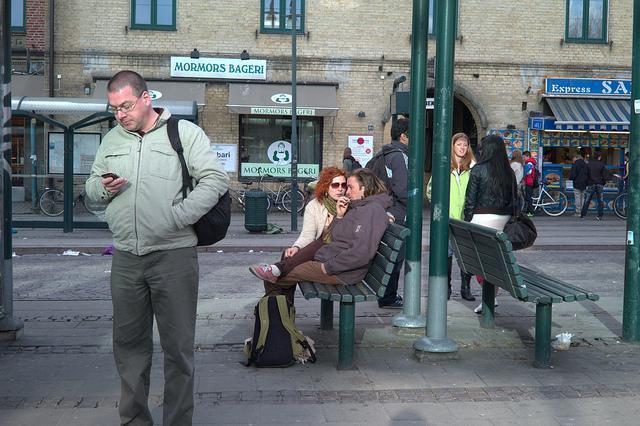How many people are sitting?
Give a very brief answer. 2. How many women are sitting down?
Give a very brief answer. 2. How many backpacks are there?
Give a very brief answer. 2. How many people can you see?
Give a very brief answer. 6. How many benches are in the picture?
Give a very brief answer. 2. 